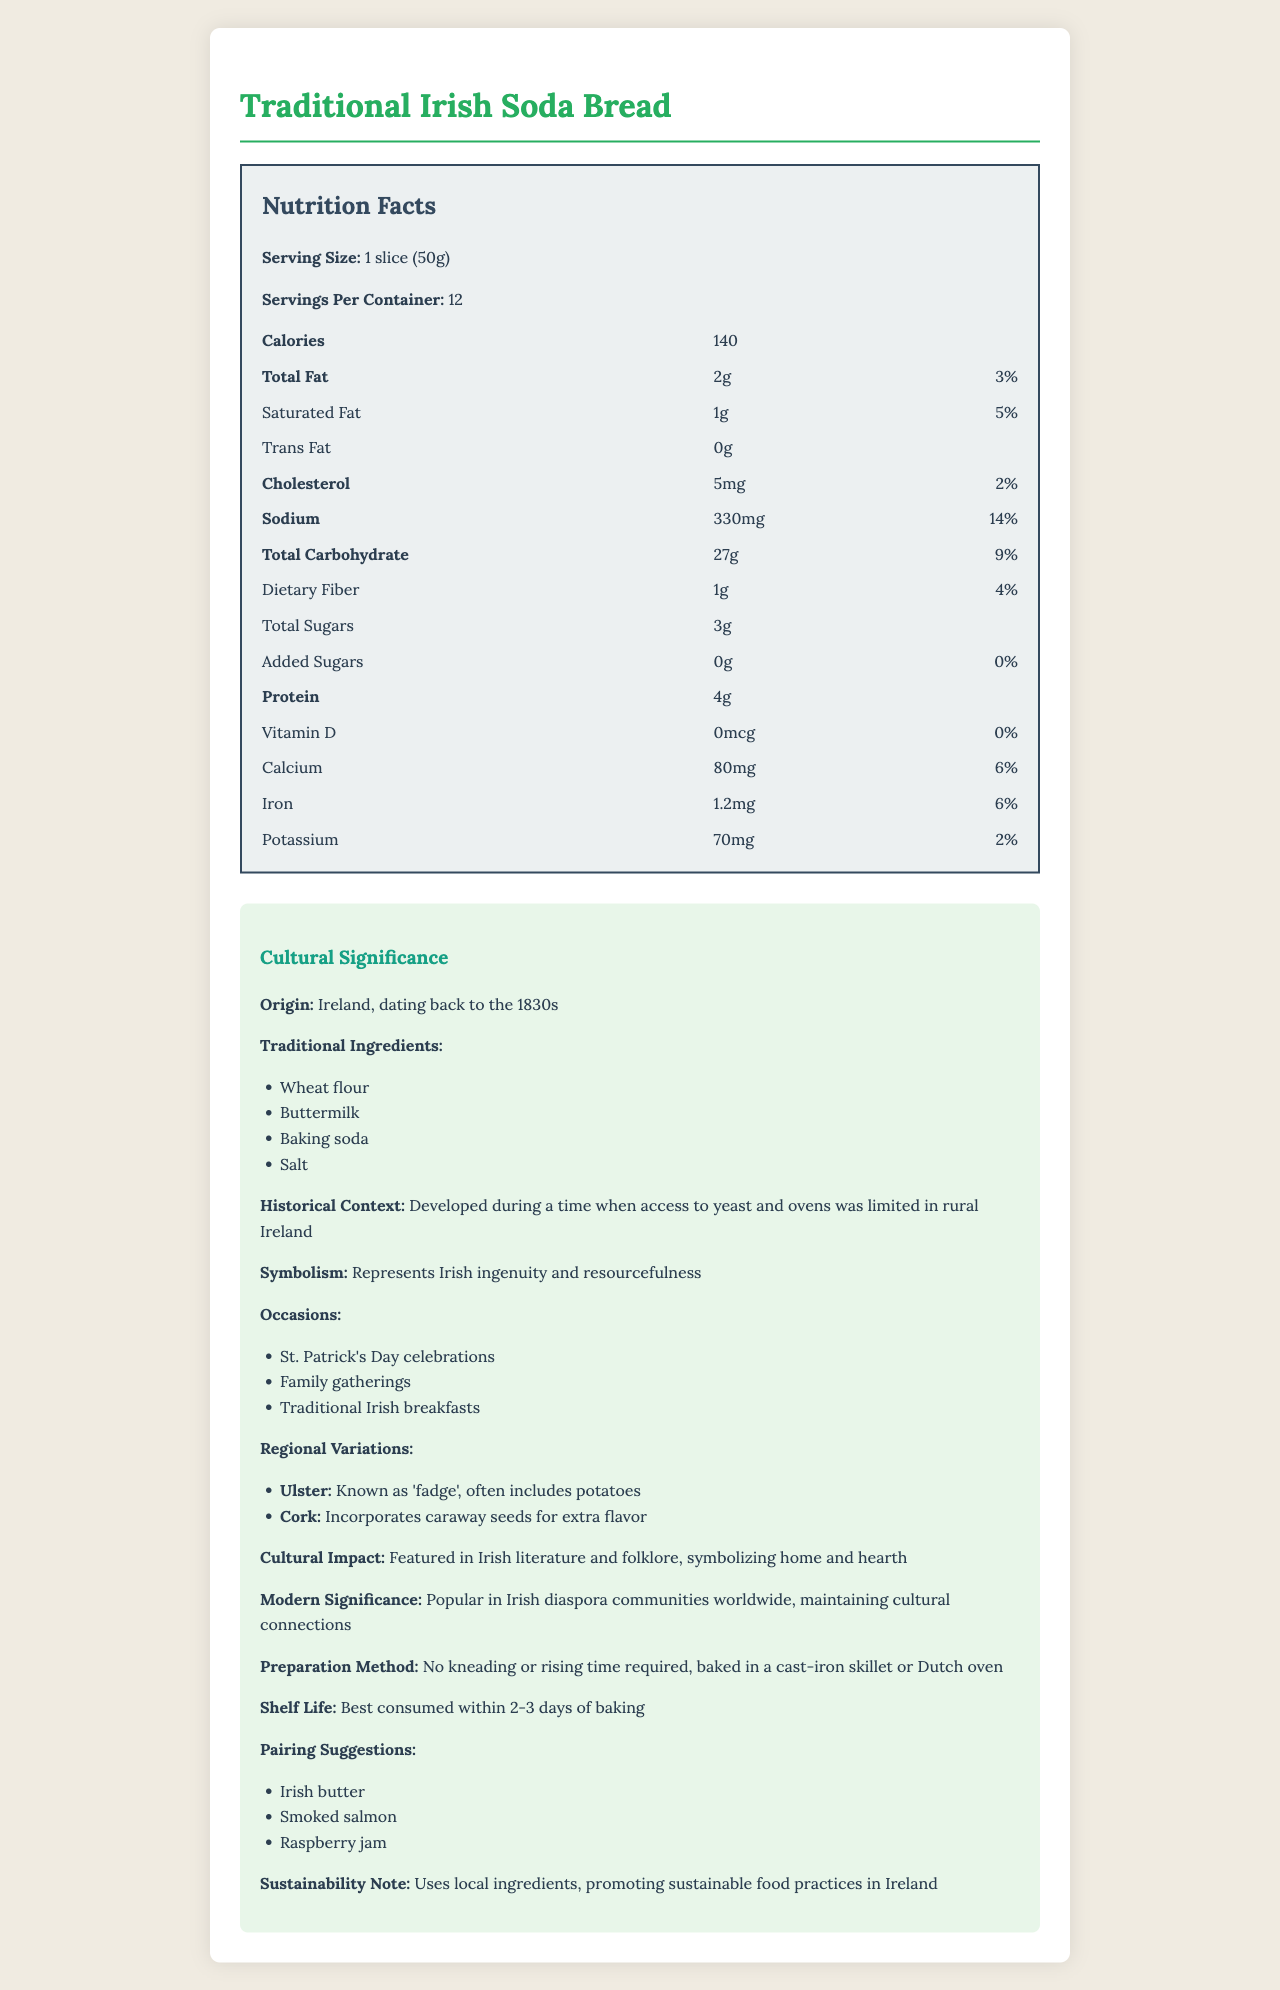what is the serving size? The serving size is explicitly mentioned as "1 slice (50g)" in the document.
Answer: 1 slice (50g) how many calories are there per serving? Each serving contains 140 calories, which is clearly stated in the Nutrition Facts section.
Answer: 140 what are the primary traditional ingredients in Traditional Irish Soda Bread? The document lists these four ingredients under the Traditional Ingredients section.
Answer: Wheat flour, Buttermilk, Baking soda, Salt what is the historical context of Traditional Irish Soda Bread? The historical context is described in the Cultural Significance section.
Answer: Developed during a time when access to yeast and ovens was limited in rural Ireland what is the sodium content per serving? The sodium content per serving is detailed as "330mg" in the Nutrition Facts section.
Answer: 330mg how much dietary fiber is in one serving of Traditional Irish Soda Bread? The document mentions "1g" as the dietary fiber content per serving.
Answer: 1g how is Traditional Irish Soda Bread significant in modern times? This information is provided in the Modern Significance part of the Cultural Significance section.
Answer: Popular in Irish diaspora communities worldwide, maintaining cultural connections what items can be served with Traditional Irish Soda Bread? A. Irish butter B. Smoked salmon C. Raspberry jam D. All of the above The document lists all three items (Irish butter, Smoked salmon, Raspberry jam) under the Pairing Suggestions section.
Answer: D. All of the above which region has a variation of soda bread that includes potatoes? 1. Ulster 2. Cork 3. Dublin 4. Galway The document specifies that in the Ulster region, soda bread is known as 'fadge' and often includes potatoes.
Answer: 1. Ulster which vitamin has a daily value of 0% in this bread? According to the Nutrition Facts, Vitamin D has a daily value of 0%.
Answer: Vitamin D is there any cholesterol in Traditional Irish Soda Bread? The document states that the bread contains 5mg of cholesterol per serving.
Answer: Yes what is the main idea of this document? The main idea is to present both nutritional and cultural information about Traditional Irish Soda Bread, giving readers insight into its health aspects and cultural importance.
Answer: The document provides comprehensive nutritional information about Traditional Irish Soda Bread and highlights its cultural significance, historical context, and modern relevance. how is Traditional Irish Soda Bread typically prepared? This preparation method is mentioned in the Preparation Method section of the document.
Answer: No kneading or rising time required, baked in a cast-iron skillet or Dutch oven how much added sugar is in the soda bread? The document states in the Nutrition Facts that the bread contains 0g of added sugars.
Answer: 0g does Traditional Irish Soda Bread contain any iron? The Nutrition Facts section mentions that there is 1.2mg of iron per serving.
Answer: Yes, 1.2mg why is Traditional Irish Soda Bread considered a symbol of Irish ingenuity and resourcefulness? The document states that it represents Irish ingenuity and resourcefulness but doesn't detail why.
Answer: Not enough information 